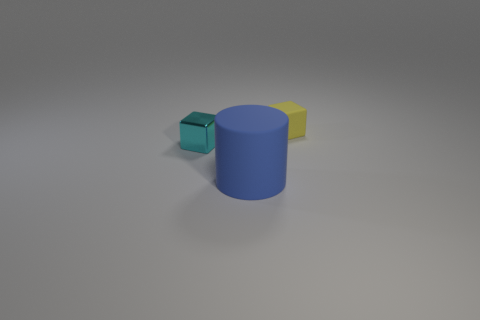What number of gray balls are the same size as the yellow matte thing?
Your response must be concise. 0. How many tiny purple rubber objects are there?
Your answer should be very brief. 0. Does the yellow block have the same material as the small block to the left of the yellow matte object?
Provide a short and direct response. No. What number of purple objects are either small blocks or matte objects?
Offer a very short reply. 0. What size is the cylinder that is the same material as the small yellow cube?
Your answer should be very brief. Large. What number of other small cyan shiny objects have the same shape as the metal thing?
Provide a short and direct response. 0. Are there more rubber cylinders in front of the small yellow matte object than big blue cylinders that are behind the cyan shiny object?
Your response must be concise. Yes. There is a cyan thing that is the same size as the yellow matte cube; what is its material?
Give a very brief answer. Metal. How many things are either big cyan metal balls or tiny cubes that are behind the metal thing?
Keep it short and to the point. 1. Does the yellow matte cube have the same size as the thing that is in front of the tiny metallic object?
Make the answer very short. No. 